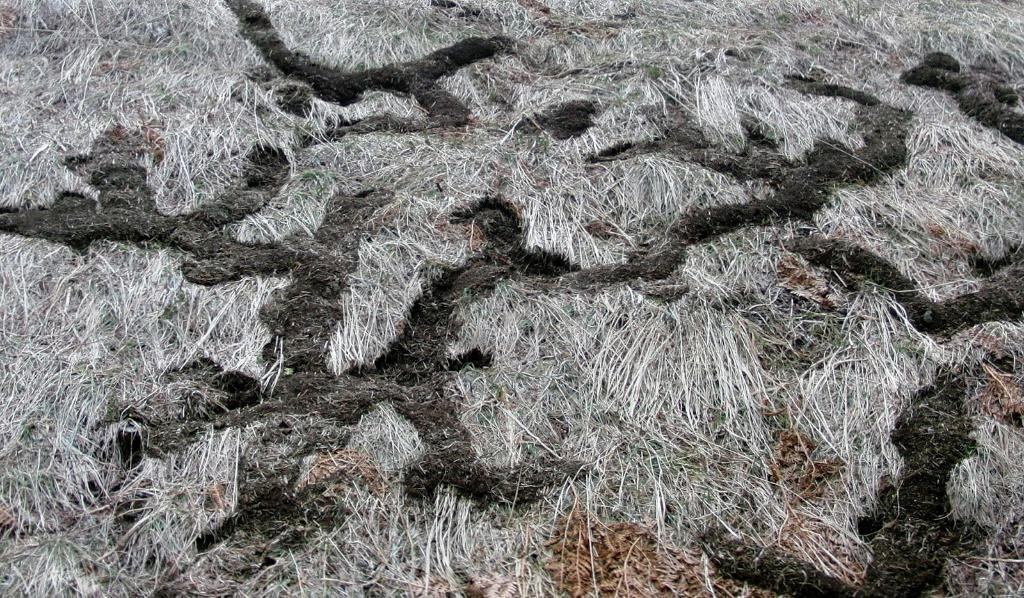What type of vegetation is present in the image? There is grass in the image. What else can be seen on the surface in the image? There are dried leaves on the surface in the image. What disease is being treated in the image? There is no indication of a disease or treatment in the image; it only features grass and dried leaves. 